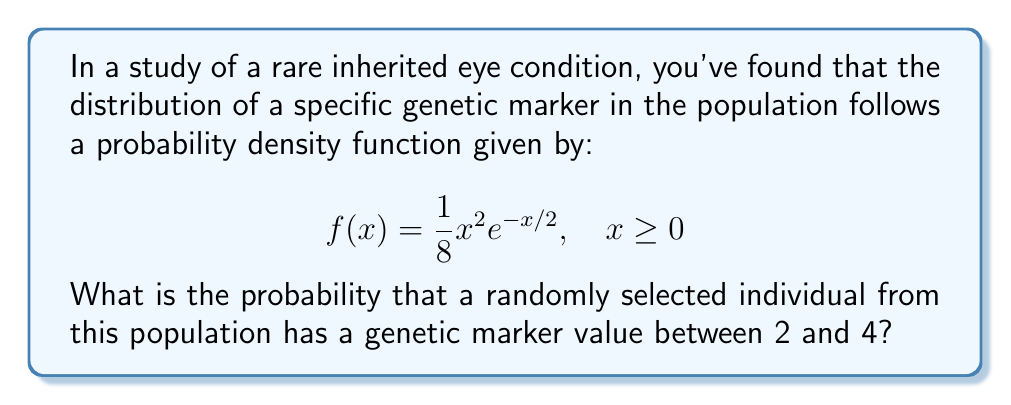Can you answer this question? To solve this problem, we need to integrate the probability density function over the given interval. Let's break it down step-by-step:

1) The probability of the genetic marker value falling between 2 and 4 is given by the integral:

   $$P(2 \leq X \leq 4) = \int_2^4 f(x) dx = \int_2^4 \frac{1}{8}x^2e^{-x/2} dx$$

2) This integral doesn't have an elementary antiderivative, so we need to use integration by parts twice. Let's set $u = x^2$ and $dv = e^{-x/2} dx$.

3) First integration by parts:
   $$\int x^2e^{-x/2} dx = -2x^2e^{-x/2} + \int 4xe^{-x/2} dx$$

4) Second integration by parts (with $u = x$ and $dv = e^{-x/2} dx$):
   $$\int 4xe^{-x/2} dx = -8xe^{-x/2} + \int 8e^{-x/2} dx = -8xe^{-x/2} - 16e^{-x/2} + C$$

5) Combining the results:
   $$\int x^2e^{-x/2} dx = -2x^2e^{-x/2} - 8xe^{-x/2} - 16e^{-x/2} + C$$

6) Now, we can evaluate the definite integral:

   $$\begin{align*}
   \frac{1}{8}\int_2^4 x^2e^{-x/2} dx &= \frac{1}{8}[-2x^2e^{-x/2} - 8xe^{-x/2} - 16e^{-x/2}]_2^4 \\
   &= \frac{1}{8}[(-32e^{-2} - 32e^{-2} - 16e^{-2}) - (-8e^{-1} - 16e^{-1} - 16e^{-1})] \\
   &= \frac{1}{8}[-80e^{-2} + 40e^{-1}] \\
   &\approx 0.1991
   \end{align*}$$

Therefore, the probability that a randomly selected individual has a genetic marker value between 2 and 4 is approximately 0.1991 or 19.91%.
Answer: 0.1991 